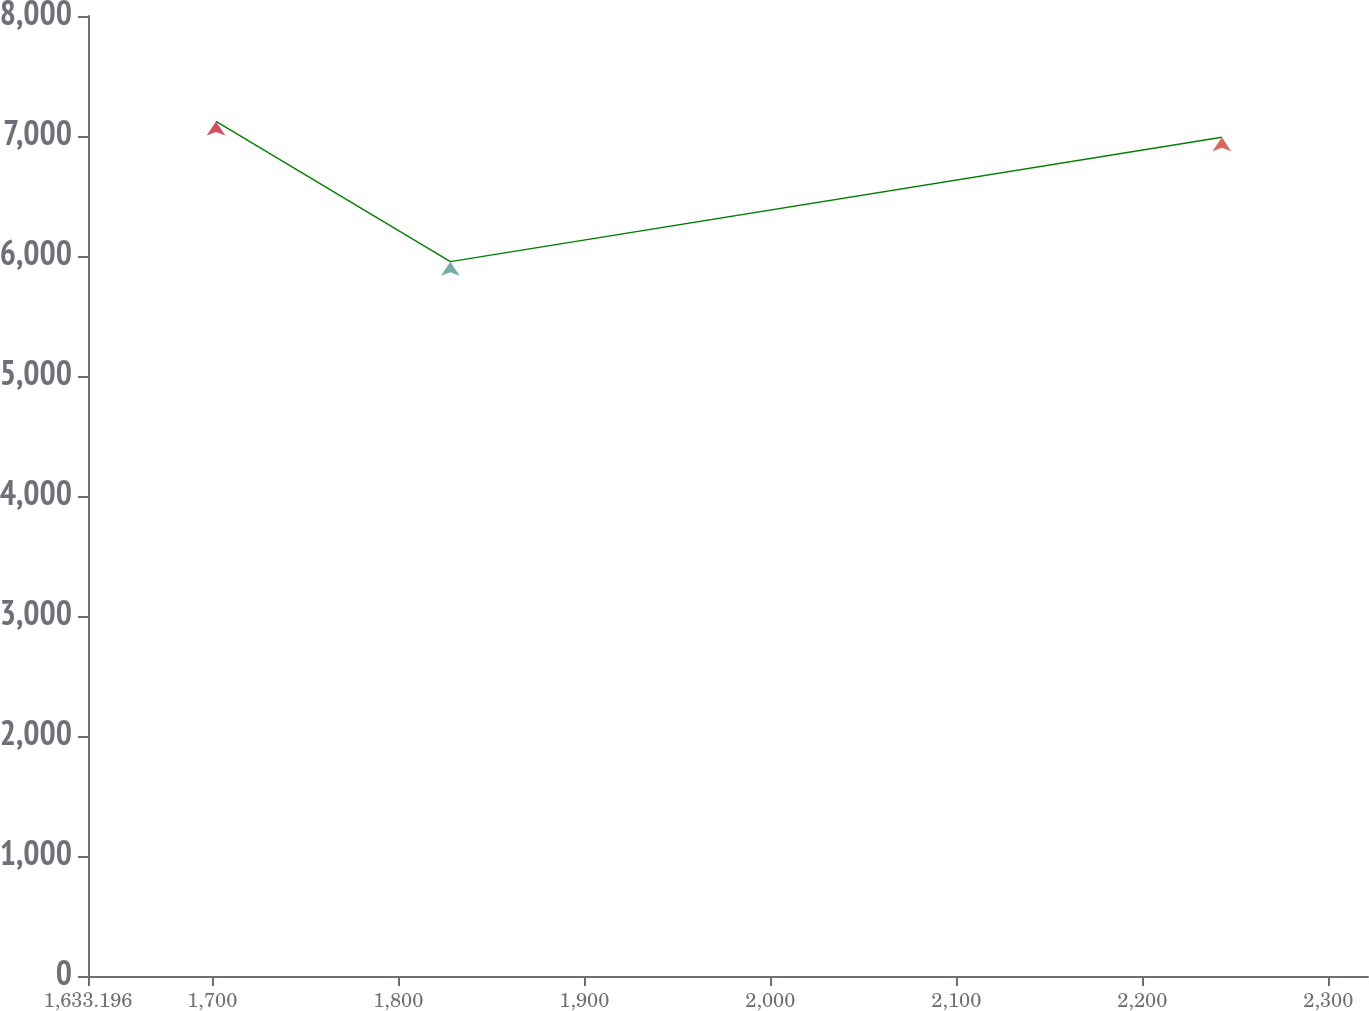<chart> <loc_0><loc_0><loc_500><loc_500><line_chart><ecel><fcel>Unnamed: 1<nl><fcel>1702.01<fcel>7121.72<nl><fcel>1828.01<fcel>5952.9<nl><fcel>2242.77<fcel>6989.94<nl><fcel>2321.61<fcel>6858.16<nl><fcel>2390.15<fcel>5800.72<nl></chart> 